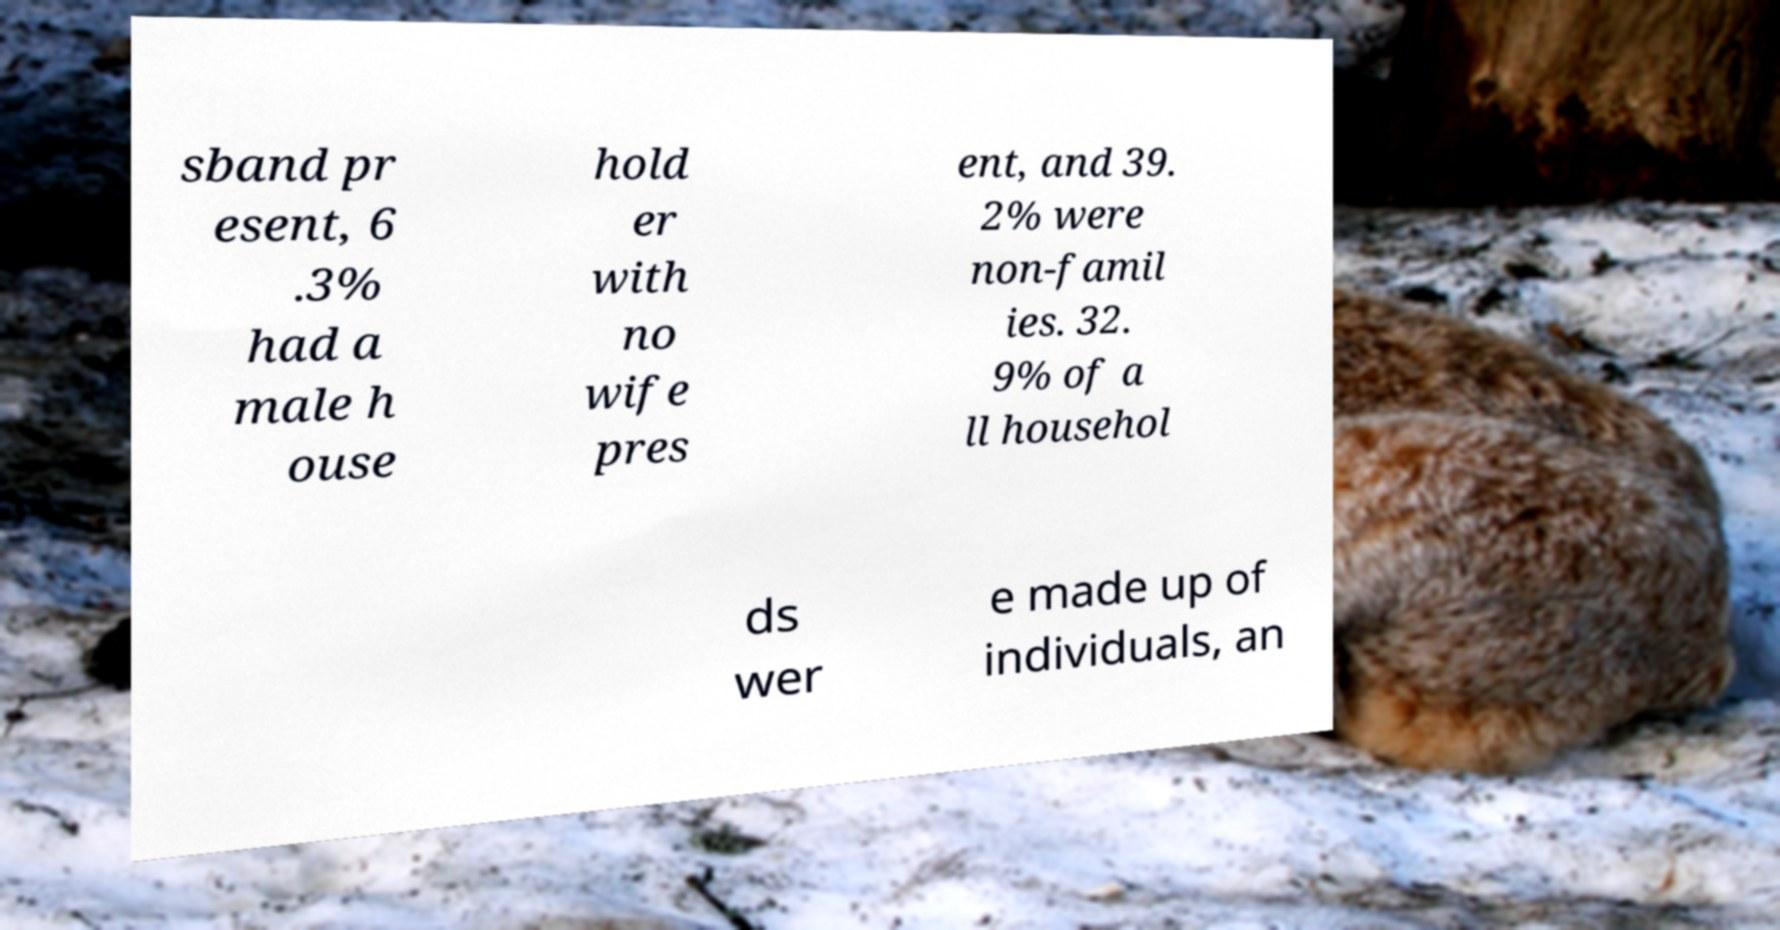Could you extract and type out the text from this image? sband pr esent, 6 .3% had a male h ouse hold er with no wife pres ent, and 39. 2% were non-famil ies. 32. 9% of a ll househol ds wer e made up of individuals, an 